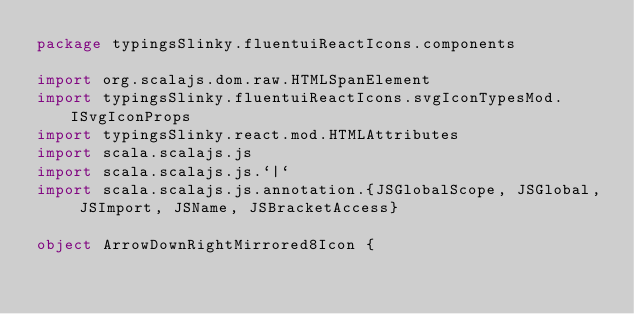<code> <loc_0><loc_0><loc_500><loc_500><_Scala_>package typingsSlinky.fluentuiReactIcons.components

import org.scalajs.dom.raw.HTMLSpanElement
import typingsSlinky.fluentuiReactIcons.svgIconTypesMod.ISvgIconProps
import typingsSlinky.react.mod.HTMLAttributes
import scala.scalajs.js
import scala.scalajs.js.`|`
import scala.scalajs.js.annotation.{JSGlobalScope, JSGlobal, JSImport, JSName, JSBracketAccess}

object ArrowDownRightMirrored8Icon {
  </code> 